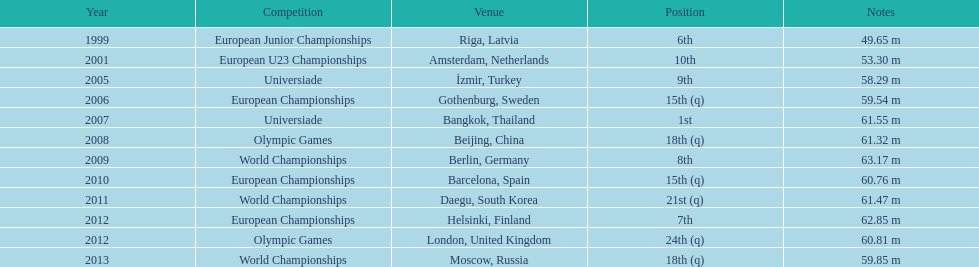Which year held the most competitions? 2012. Would you be able to parse every entry in this table? {'header': ['Year', 'Competition', 'Venue', 'Position', 'Notes'], 'rows': [['1999', 'European Junior Championships', 'Riga, Latvia', '6th', '49.65 m'], ['2001', 'European U23 Championships', 'Amsterdam, Netherlands', '10th', '53.30 m'], ['2005', 'Universiade', 'İzmir, Turkey', '9th', '58.29 m'], ['2006', 'European Championships', 'Gothenburg, Sweden', '15th (q)', '59.54 m'], ['2007', 'Universiade', 'Bangkok, Thailand', '1st', '61.55 m'], ['2008', 'Olympic Games', 'Beijing, China', '18th (q)', '61.32 m'], ['2009', 'World Championships', 'Berlin, Germany', '8th', '63.17 m'], ['2010', 'European Championships', 'Barcelona, Spain', '15th (q)', '60.76 m'], ['2011', 'World Championships', 'Daegu, South Korea', '21st (q)', '61.47 m'], ['2012', 'European Championships', 'Helsinki, Finland', '7th', '62.85 m'], ['2012', 'Olympic Games', 'London, United Kingdom', '24th (q)', '60.81 m'], ['2013', 'World Championships', 'Moscow, Russia', '18th (q)', '59.85 m']]} 